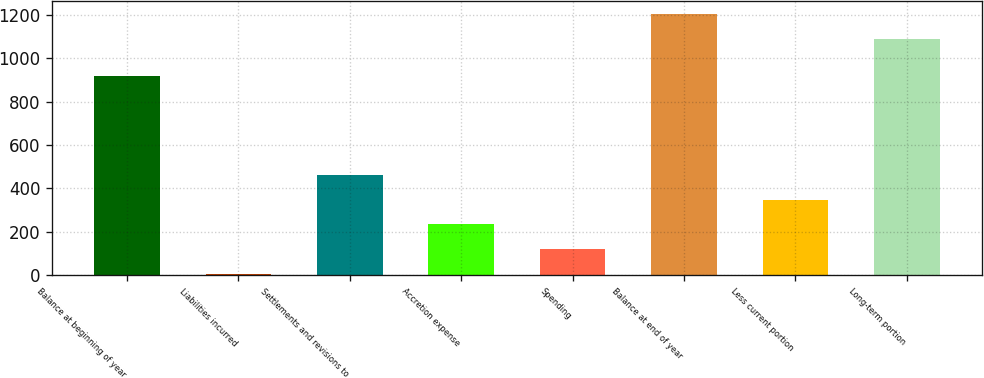<chart> <loc_0><loc_0><loc_500><loc_500><bar_chart><fcel>Balance at beginning of year<fcel>Liabilities incurred<fcel>Settlements and revisions to<fcel>Accretion expense<fcel>Spending<fcel>Balance at end of year<fcel>Less current portion<fcel>Long-term portion<nl><fcel>921<fcel>6<fcel>462<fcel>234<fcel>120<fcel>1205<fcel>348<fcel>1091<nl></chart> 